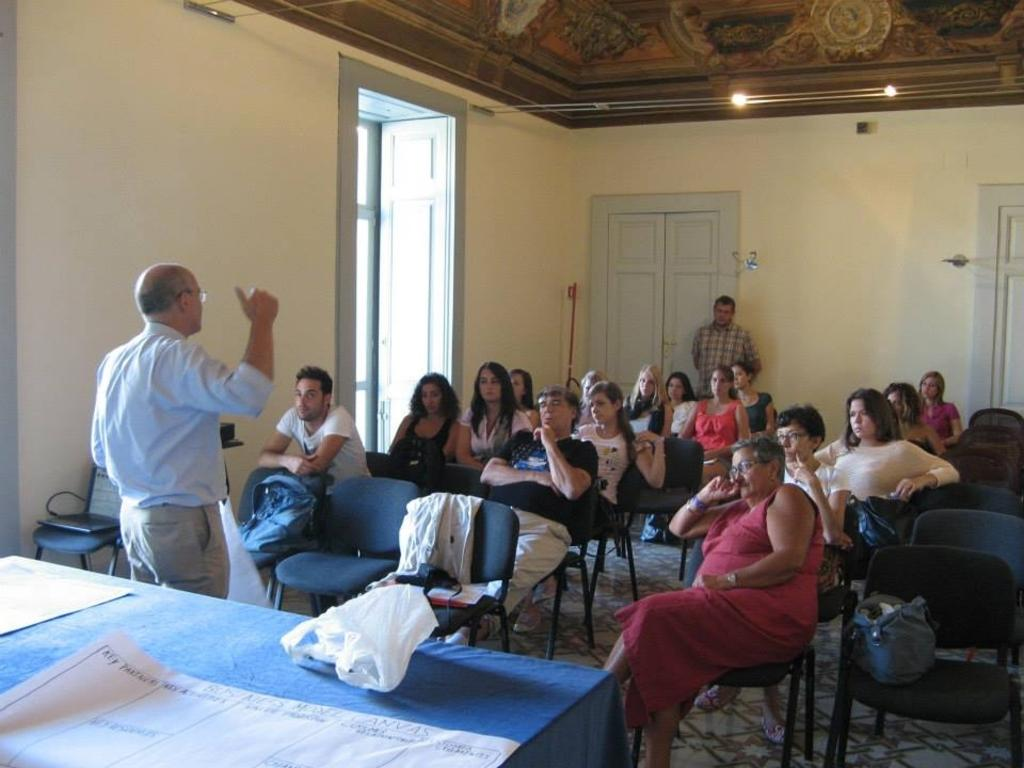How many people are in the image? There is a group of people in the image. What are some of the people doing in the image? Some of the people are sitting on chairs, while two persons are standing. What can be seen in the background of the image? There is a window, a door, and light visible in the background. Can you see any ghosts playing with pleasure in the image? There are no ghosts or any indication of pleasure present in the image. 